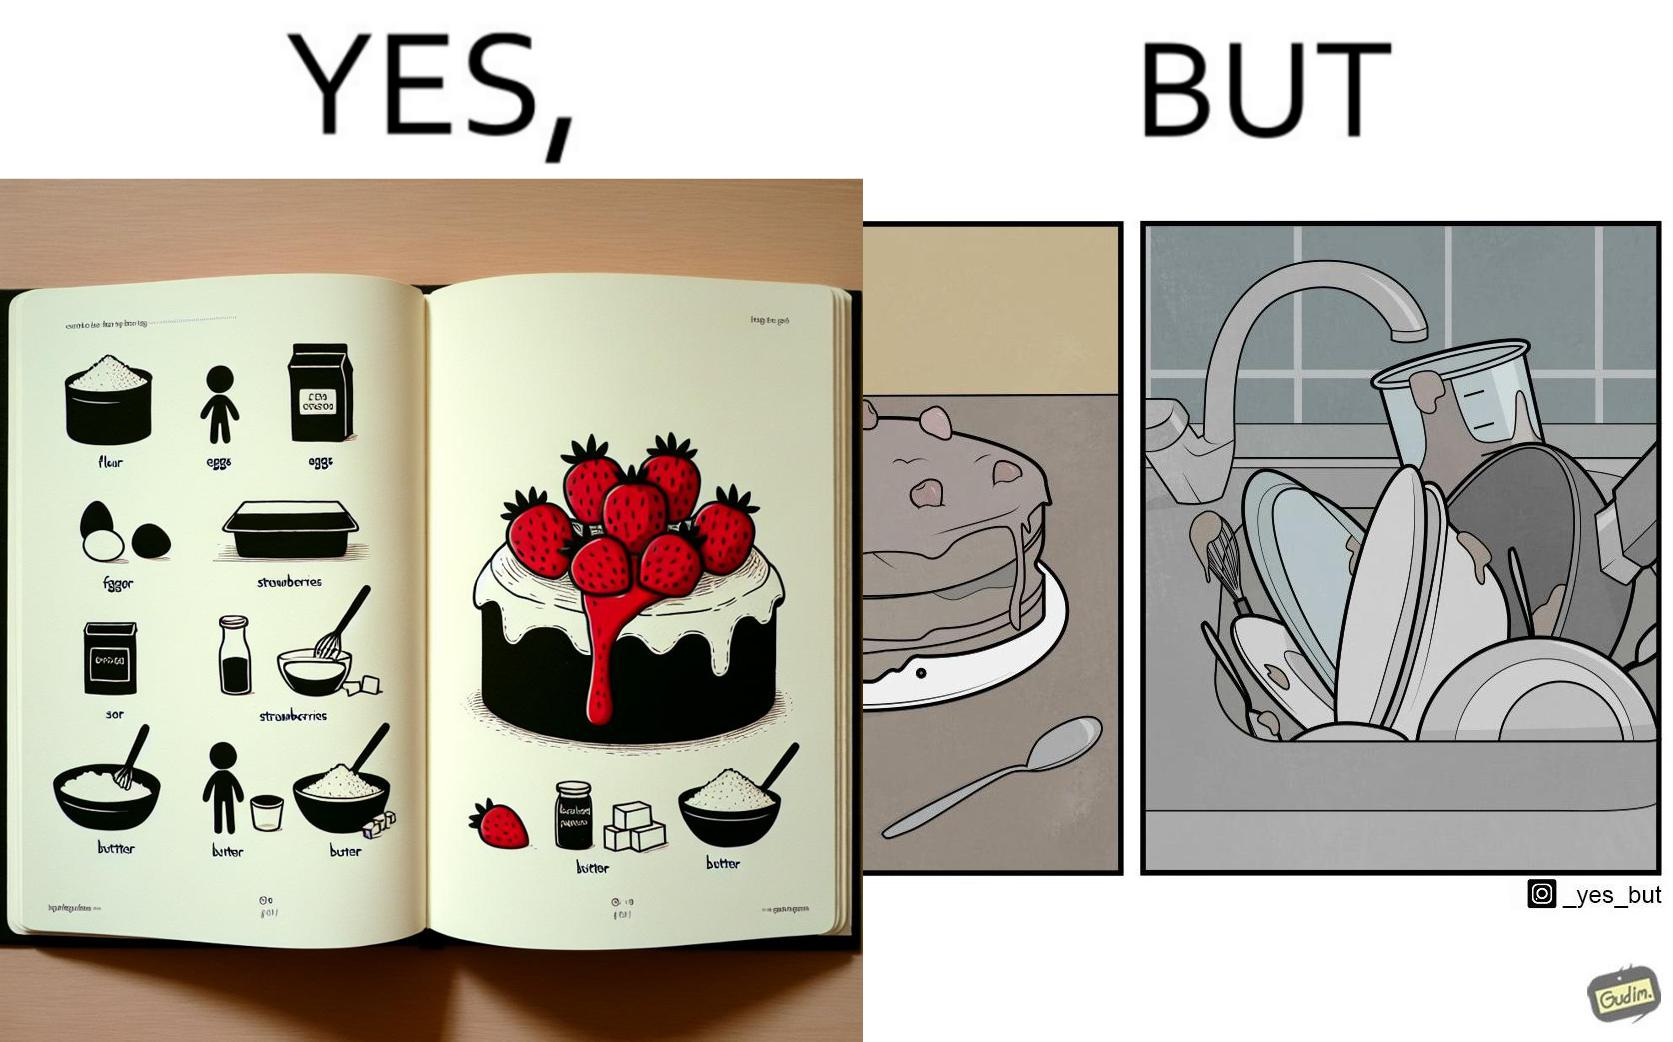Describe what you see in this image. The image is funny, as when making a strawberry cake using  a recipe book, the outcome is not quite what is expected, and one has to wash the used utensils afterwards as well. 